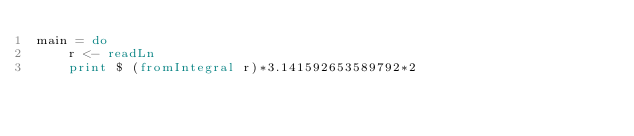<code> <loc_0><loc_0><loc_500><loc_500><_Haskell_>main = do
    r <- readLn
    print $ (fromIntegral r)*3.141592653589792*2</code> 